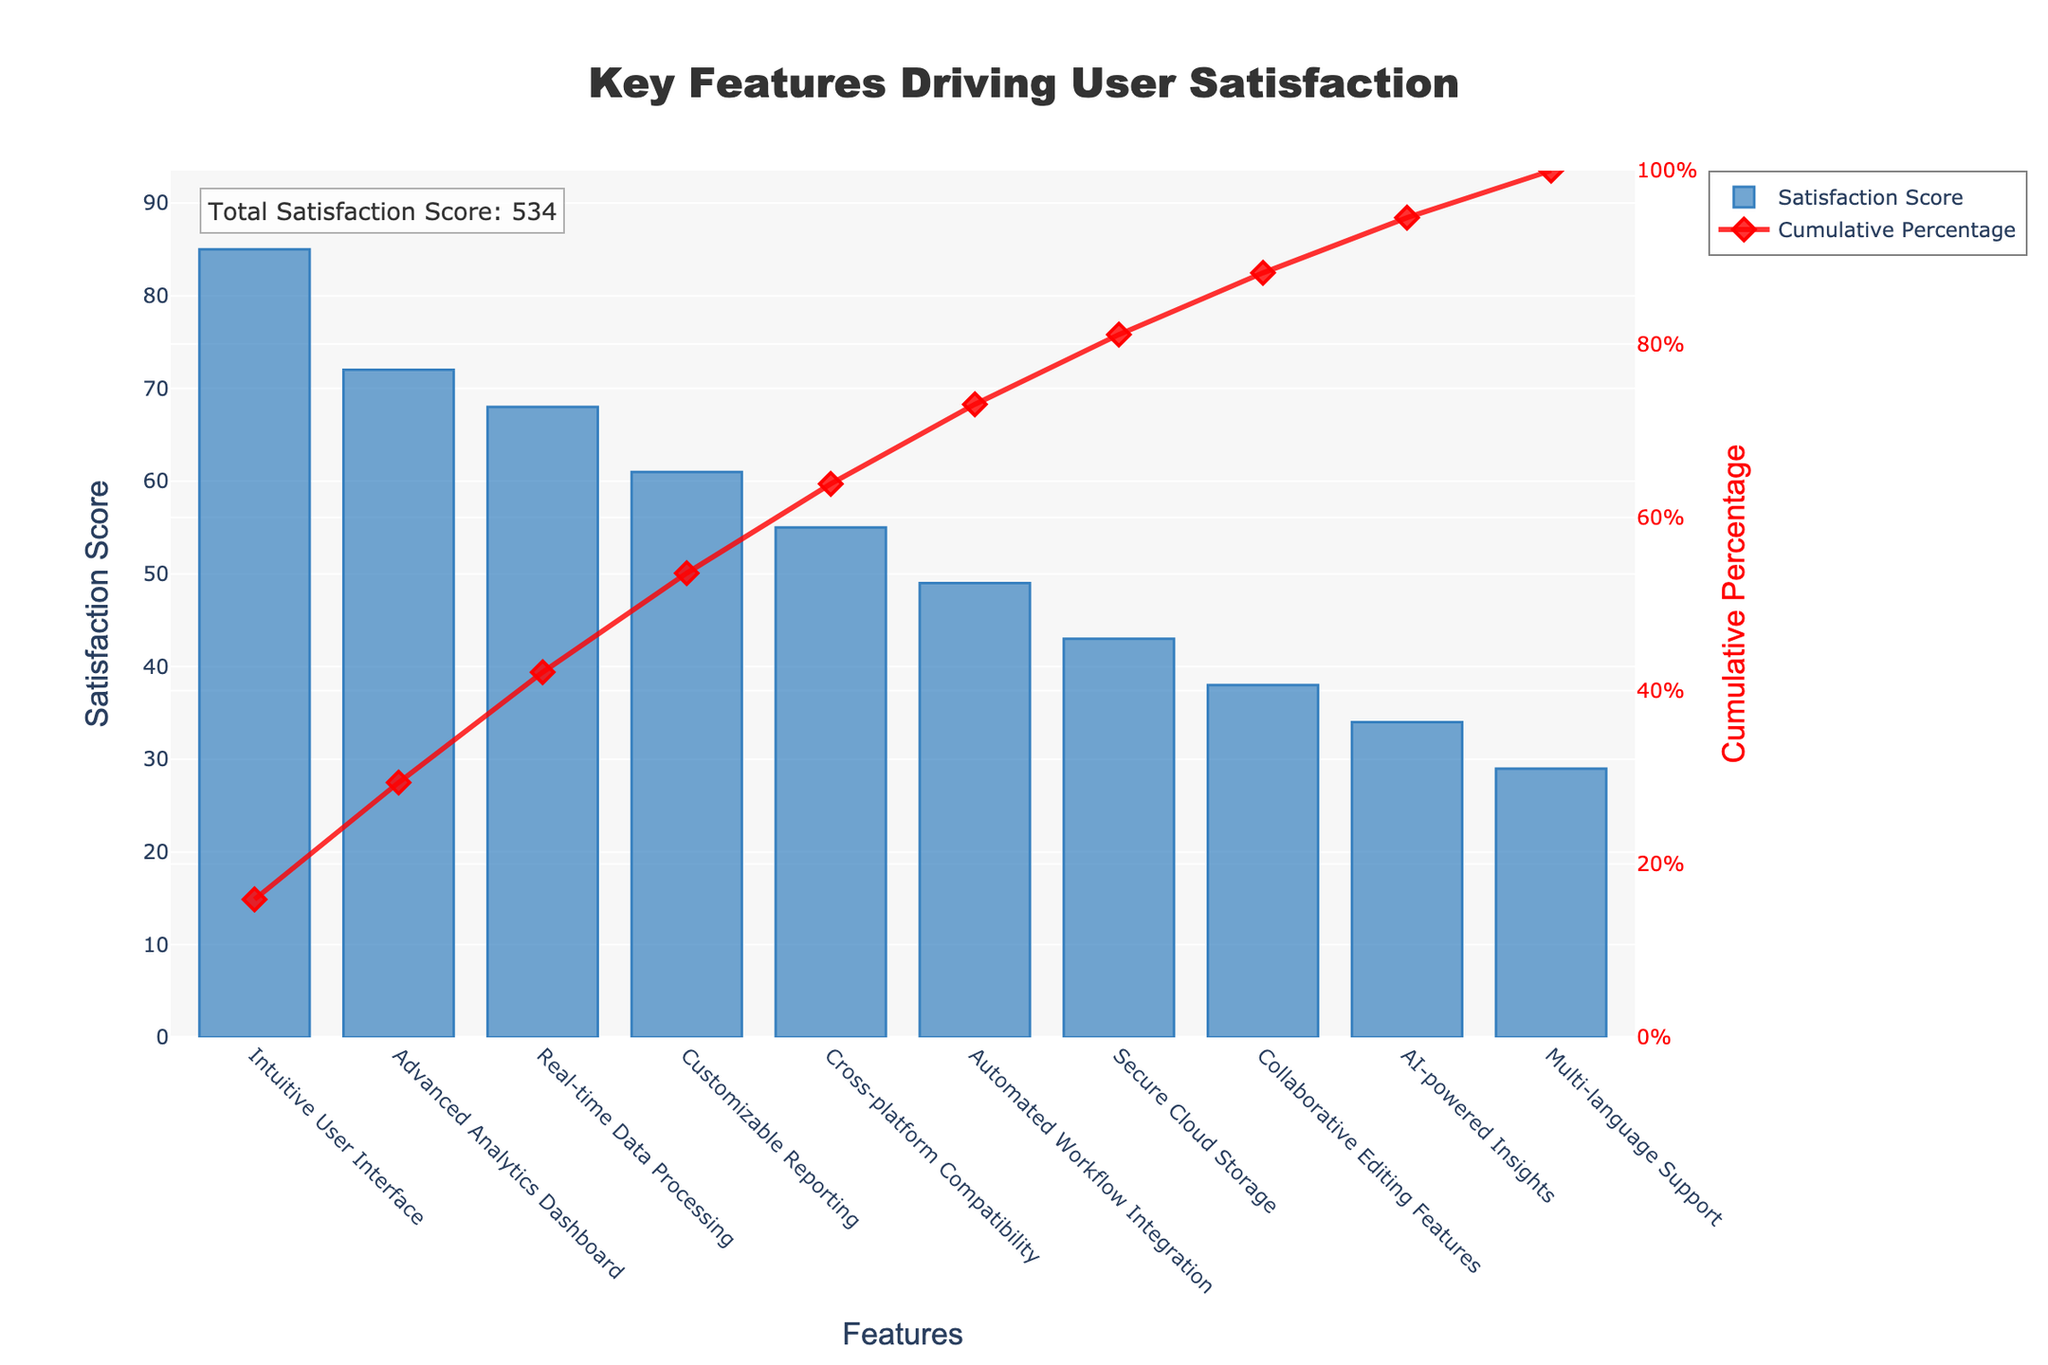What's the title of the chart? Look at the top of the chart where the title is written prominently in a large, bold font.
Answer: Key Features Driving User Satisfaction Which feature has the highest satisfaction score? Identify the highest bar on the left side of the chart and check the label on the x-axis associated with it.
Answer: Intuitive User Interface What is the cumulative percentage for the feature 'Customizable Reporting'? Locate the bar labeled 'Customizable Reporting' on the x-axis and then look at the corresponding point on the red line representing cumulative percentage.
Answer: Approximately 72% What’s the range of satisfaction scores presented in the chart? Find the highest and lowest bars on the y-axis and note their associated satisfaction scores. The lowest satisfaction score can be found by checking the smallest bar height.
Answer: 29 to 85 How much higher is the satisfaction score of 'Advanced Analytics Dashboard' compared to 'AI-powered Insights'? Find the satisfaction scores of both features from their respective bars and subtract the latter from the former. (72 - 34)
Answer: 38 What cumulative percentage does the feature 'Real-time Data Processing' contribute to? Look at the cumulative percentage line above the 'Real-time Data Processing' bar and find its value on the right y-axis.
Answer: Approximately 70% What is the total satisfaction score of all features combined? The chart provides a specific annotation at the top-left corner mentioning the total satisfaction score using the sum of individual scores.
Answer: 504 Which feature has the lowest satisfaction score? Identify the shortest bar on the chart and check its label on the x-axis.
Answer: Multi-language Support Compare the satisfaction scores of 'Cross-platform Compatibility' and 'Customizable Reporting'. Which one is higher and by how much? Find the bars for both features on the x-axis, check their heights, and then subtract the smaller satisfaction score from the larger one. (61 - 55)
Answer: Customizable Reporting is higher by 6 What percentage does 'Secure Cloud Storage' contribute to the cumulative percentage? Find the 'Secure Cloud Storage' bar, and check the cumulative percentage indicated by the corresponding point on the red line.
Answer: Approximately 78% 